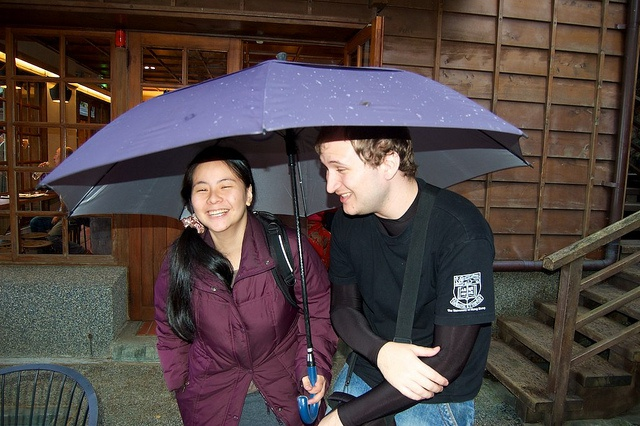Describe the objects in this image and their specific colors. I can see people in black, white, gray, and tan tones, umbrella in black, gray, and darkgray tones, people in black and purple tones, chair in black, gray, blue, and darkgreen tones, and handbag in black and purple tones in this image. 